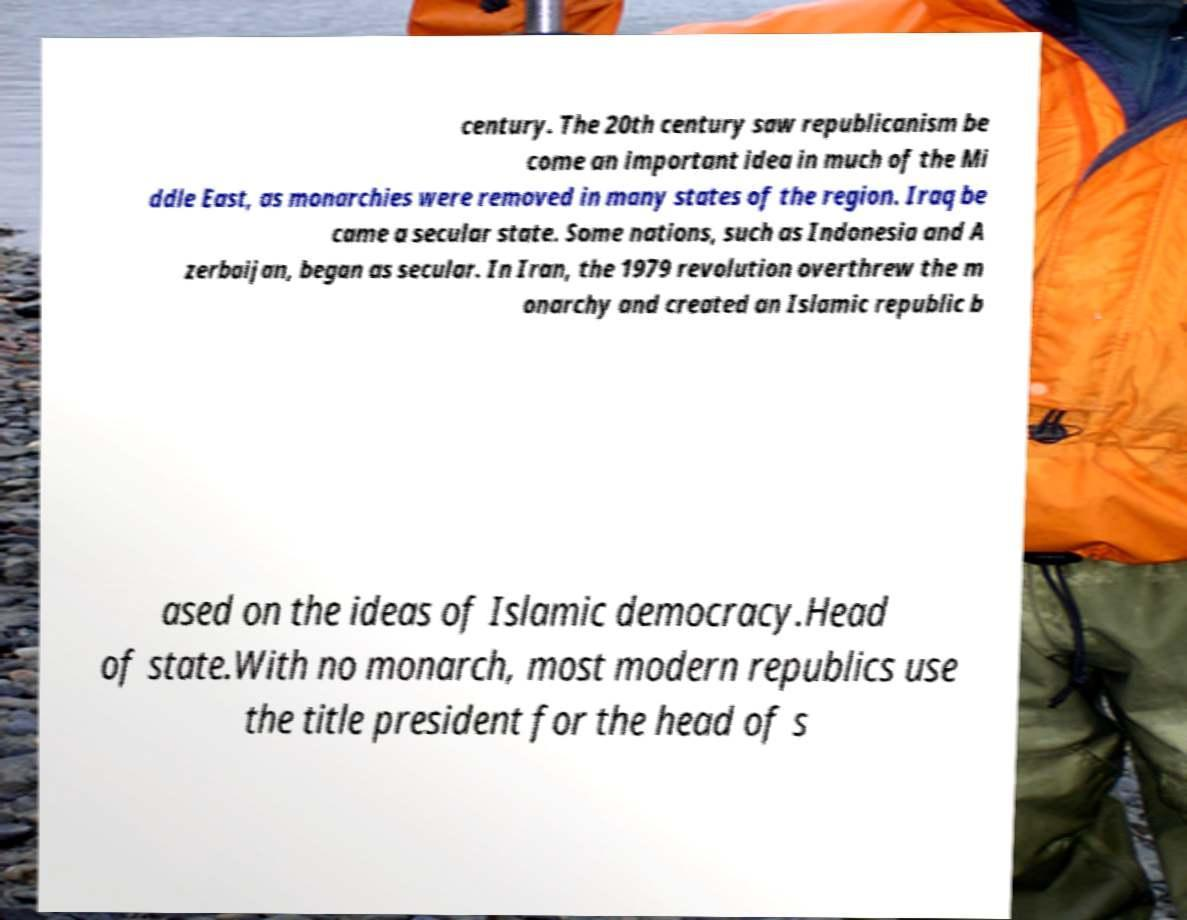Please identify and transcribe the text found in this image. century. The 20th century saw republicanism be come an important idea in much of the Mi ddle East, as monarchies were removed in many states of the region. Iraq be came a secular state. Some nations, such as Indonesia and A zerbaijan, began as secular. In Iran, the 1979 revolution overthrew the m onarchy and created an Islamic republic b ased on the ideas of Islamic democracy.Head of state.With no monarch, most modern republics use the title president for the head of s 